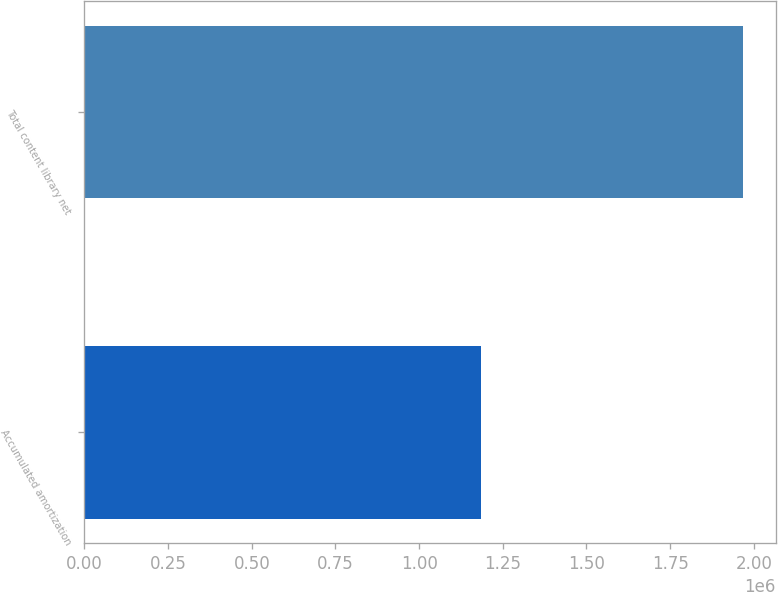<chart> <loc_0><loc_0><loc_500><loc_500><bar_chart><fcel>Accumulated amortization<fcel>Total content library net<nl><fcel>1.1848e+06<fcel>1.96664e+06<nl></chart> 